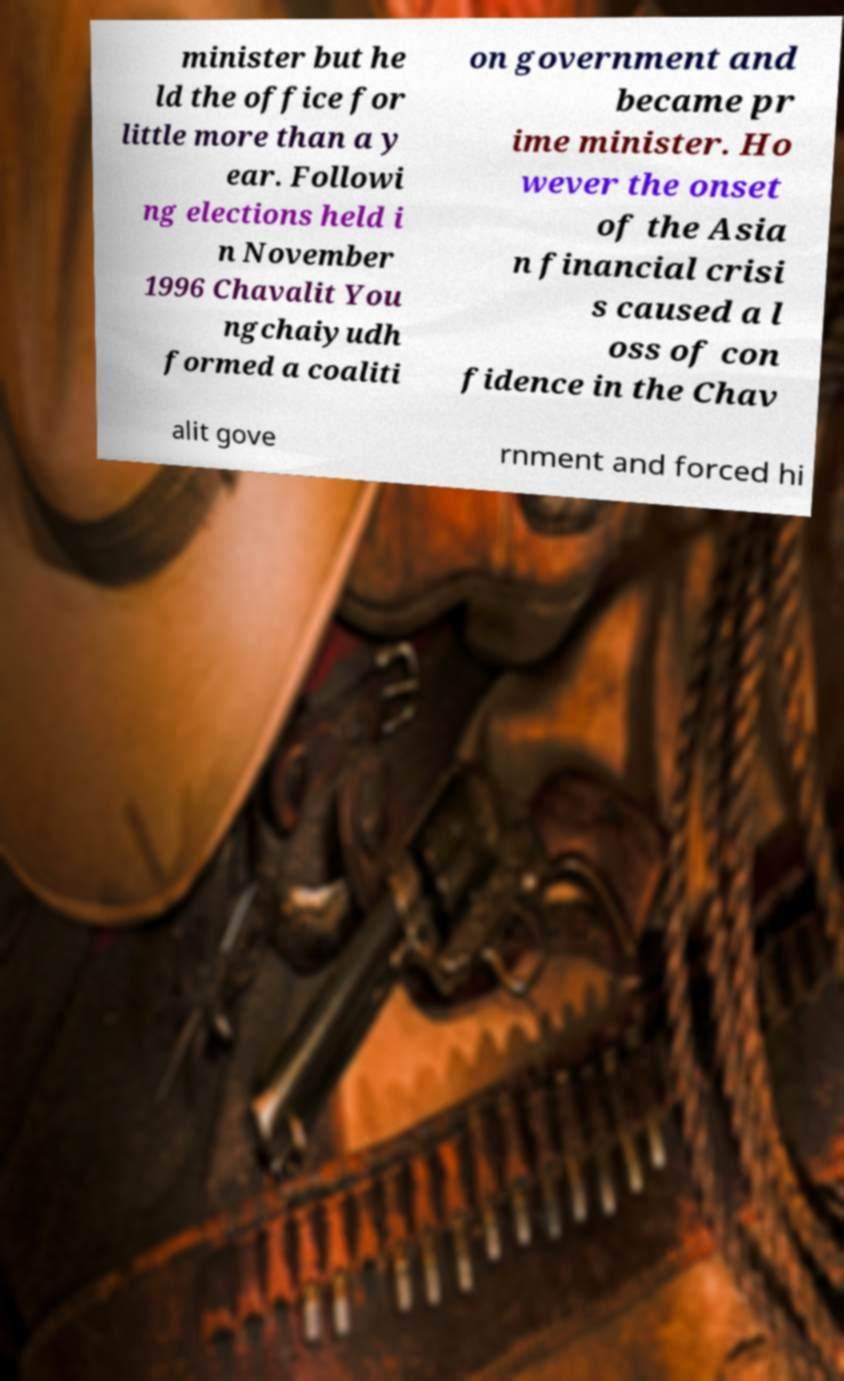Please read and relay the text visible in this image. What does it say? minister but he ld the office for little more than a y ear. Followi ng elections held i n November 1996 Chavalit You ngchaiyudh formed a coaliti on government and became pr ime minister. Ho wever the onset of the Asia n financial crisi s caused a l oss of con fidence in the Chav alit gove rnment and forced hi 